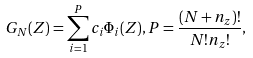Convert formula to latex. <formula><loc_0><loc_0><loc_500><loc_500>G _ { N } ( Z ) = \sum _ { i = 1 } ^ { P } c _ { i } \Phi _ { i } ( Z ) , P = \frac { ( N + n _ { z } ) ! } { N ! n _ { z } ! } ,</formula> 